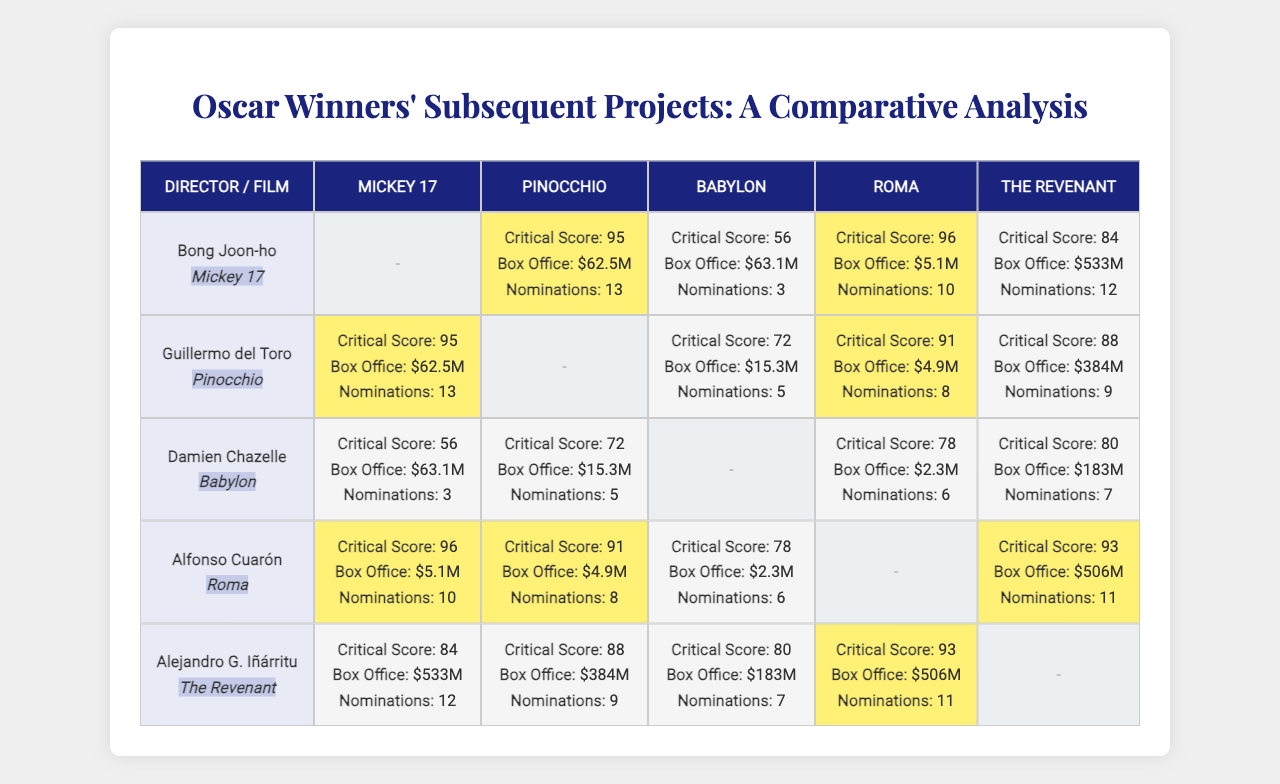What is the critical score for "Mickey 17"? In the table, the critical score for "Mickey 17" can be found in the row corresponding to its director, Bong Joon-ho. The score is shown directly in the cell without any additional calculations.
Answer: 95 Which film directed by Guillermo del Toro received the highest box office earnings? Looking at Guillermo del Toro's row, the box office earnings for his films are listed. The highest value among these is 63.1 million, which corresponds to "Pinocchio".
Answer: Pinocchio How many nominations did "Babylon" receive? To find the number of nominations for "Babylon", locate the column labeled "Babylon" and find the respective value in the rows for each director. The number of nominations is 3.
Answer: 3 Which director had the highest critical score for their film following their Oscar win? Comparing the critical scores among all directors for their respective films, Alfonso Cuarón's "Roma" has the highest critical score of 96.
Answer: Alfonso Cuarón What is the average box office for films directed by Alejandro G. Iñárritu? The box office values for Alejandro G. Iñárritu's films are 533, 384, 183, and 506 million. Summing these: 533 + 384 + 183 + 506 = 1606, and then dividing by the number of films (4) gives an average of 401.5 million.
Answer: 401.5 million Did any film directed by Damien Chazelle receive a critical score above 80? Checking the critical scores for Damien Chazelle's films, the scores are 56 (Mickey 17), 72 (Pinocchio), 78 (Babylon),  null (Roma), and 80 (The Revenant). "The Revenant" is the only film with a score of 80 or higher, thus confirming the answer is yes.
Answer: Yes What is the difference in nominations between Bong Joon-ho's "Mickey 17" and Guillermo del Toro's "Pinocchio"? From the award nominations, Bong Joon-ho's "Mickey 17" has 13 nominations, while Guillermo del Toro's "Pinocchio" has 5. The difference is 13 - 5 = 8 nominations.
Answer: 8 Which film had the lowest box office gross, and what was the amount? From the table, the lowest box office gross is 2.3 million for Damien Chazelle's "Babylon". No calculations are necessary since the value is directly visible in the table.
Answer: 2.3 million What percentage of critical scores for films directed by Alejandro G. Iñárritu are above 80? The critical scores for Alejandro G. Iñárritu's films are 84, 88, 80, and 93. Out of these four scores, three (84, 88, and 93) are above 80, making the percentage 3 out of 4, or 75%.
Answer: 75% 